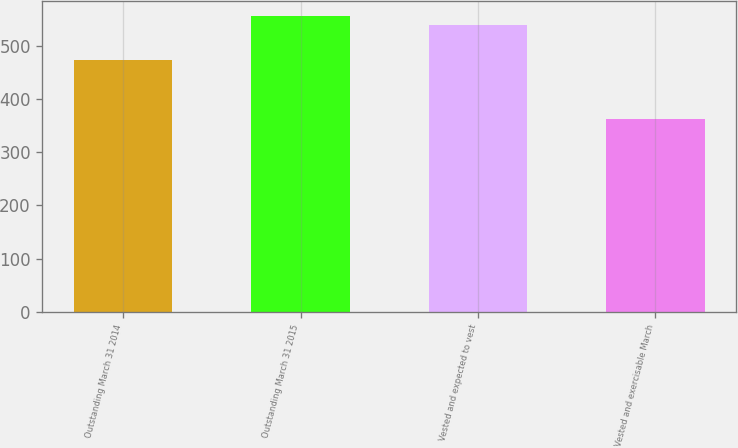<chart> <loc_0><loc_0><loc_500><loc_500><bar_chart><fcel>Outstanding March 31 2014<fcel>Outstanding March 31 2015<fcel>Vested and expected to vest<fcel>Vested and exercisable March<nl><fcel>473<fcel>555.6<fcel>538<fcel>363<nl></chart> 